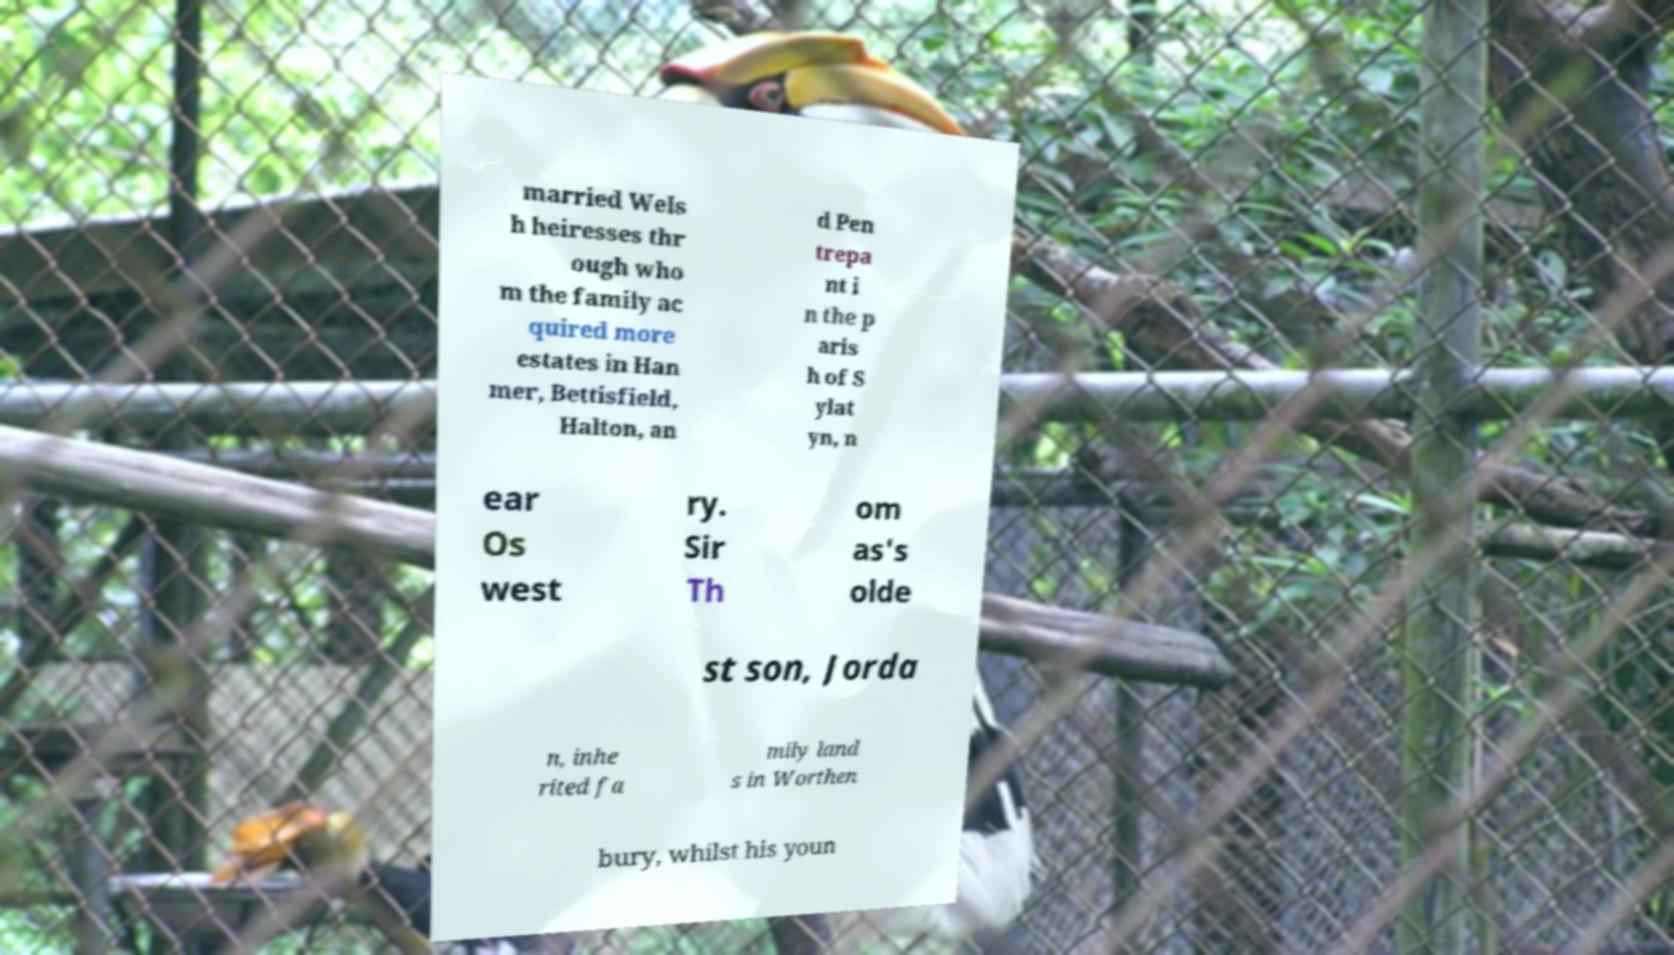Please read and relay the text visible in this image. What does it say? married Wels h heiresses thr ough who m the family ac quired more estates in Han mer, Bettisfield, Halton, an d Pen trepa nt i n the p aris h of S ylat yn, n ear Os west ry. Sir Th om as's olde st son, Jorda n, inhe rited fa mily land s in Worthen bury, whilst his youn 